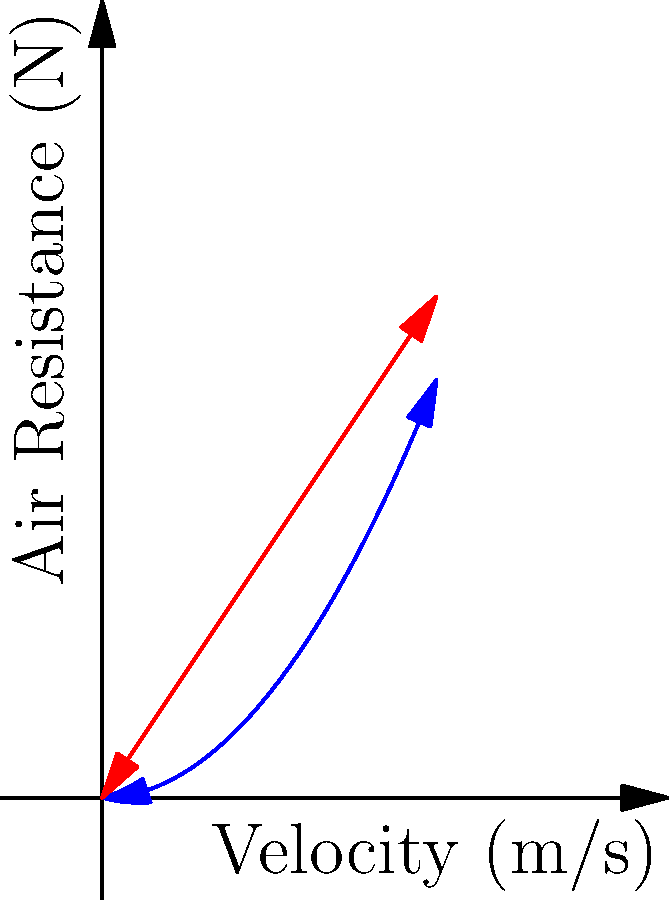During a crucial Vikings game, the punter kicks a football with a velocity of 20 m/s. Given that the air resistance on a football (blue curve) is approximately half that of a sphere (red curve) of the same size due to its aerodynamic shape, estimate the air resistance force on the football at this velocity. Assume the air resistance on a sphere at 20 m/s is 60 N. Let's approach this step-by-step:

1) The graph shows that the air resistance for both the football and the sphere increases with velocity, but at different rates.

2) We're told that the air resistance on a football is approximately half that of a sphere of the same size.

3) We're given that the air resistance on a sphere at 20 m/s is 60 N.

4) To find the air resistance on the football, we need to take half of the sphere's air resistance:

   $$F_{football} = \frac{1}{2} F_{sphere}$$

5) Plugging in the values:

   $$F_{football} = \frac{1}{2} (60 \text{ N}) = 30 \text{ N}$$

6) Therefore, the estimated air resistance force on the football at 20 m/s is 30 N.

This reduced air resistance is why footballs are designed with their characteristic shape, allowing for longer punts and passes in games.
Answer: 30 N 